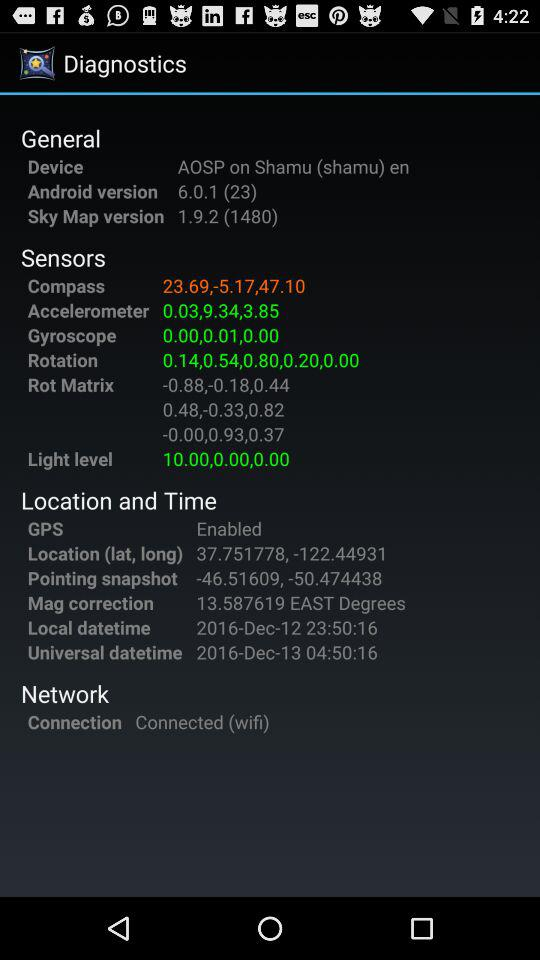What is the local datetime? The local datetime is December 12, 2016 and 23:50:16, respectively. 